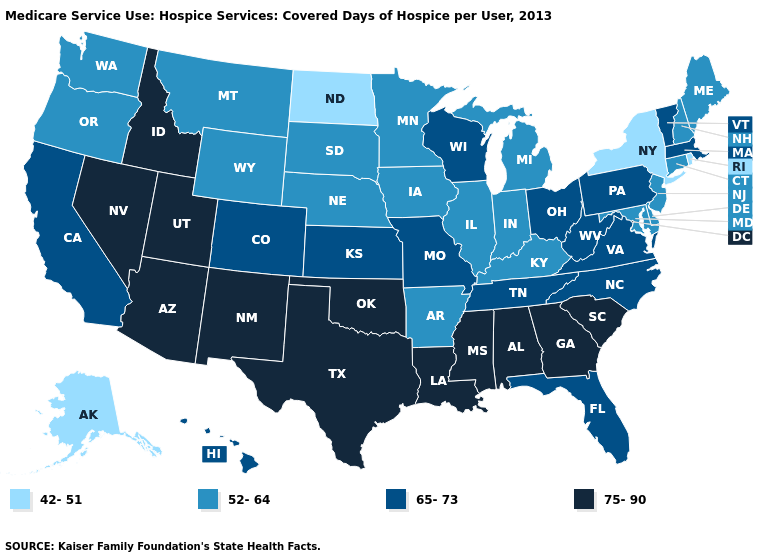Does the map have missing data?
Concise answer only. No. Does the first symbol in the legend represent the smallest category?
Quick response, please. Yes. Does Maryland have the highest value in the USA?
Short answer required. No. What is the highest value in the MidWest ?
Short answer required. 65-73. What is the value of Oregon?
Give a very brief answer. 52-64. What is the highest value in the USA?
Answer briefly. 75-90. What is the highest value in the South ?
Answer briefly. 75-90. What is the value of New Hampshire?
Give a very brief answer. 52-64. What is the value of Wyoming?
Concise answer only. 52-64. Among the states that border Idaho , does Nevada have the highest value?
Give a very brief answer. Yes. Does Washington have a lower value than Oklahoma?
Concise answer only. Yes. Name the states that have a value in the range 75-90?
Answer briefly. Alabama, Arizona, Georgia, Idaho, Louisiana, Mississippi, Nevada, New Mexico, Oklahoma, South Carolina, Texas, Utah. Name the states that have a value in the range 42-51?
Quick response, please. Alaska, New York, North Dakota, Rhode Island. How many symbols are there in the legend?
Be succinct. 4. Which states have the highest value in the USA?
Be succinct. Alabama, Arizona, Georgia, Idaho, Louisiana, Mississippi, Nevada, New Mexico, Oklahoma, South Carolina, Texas, Utah. 